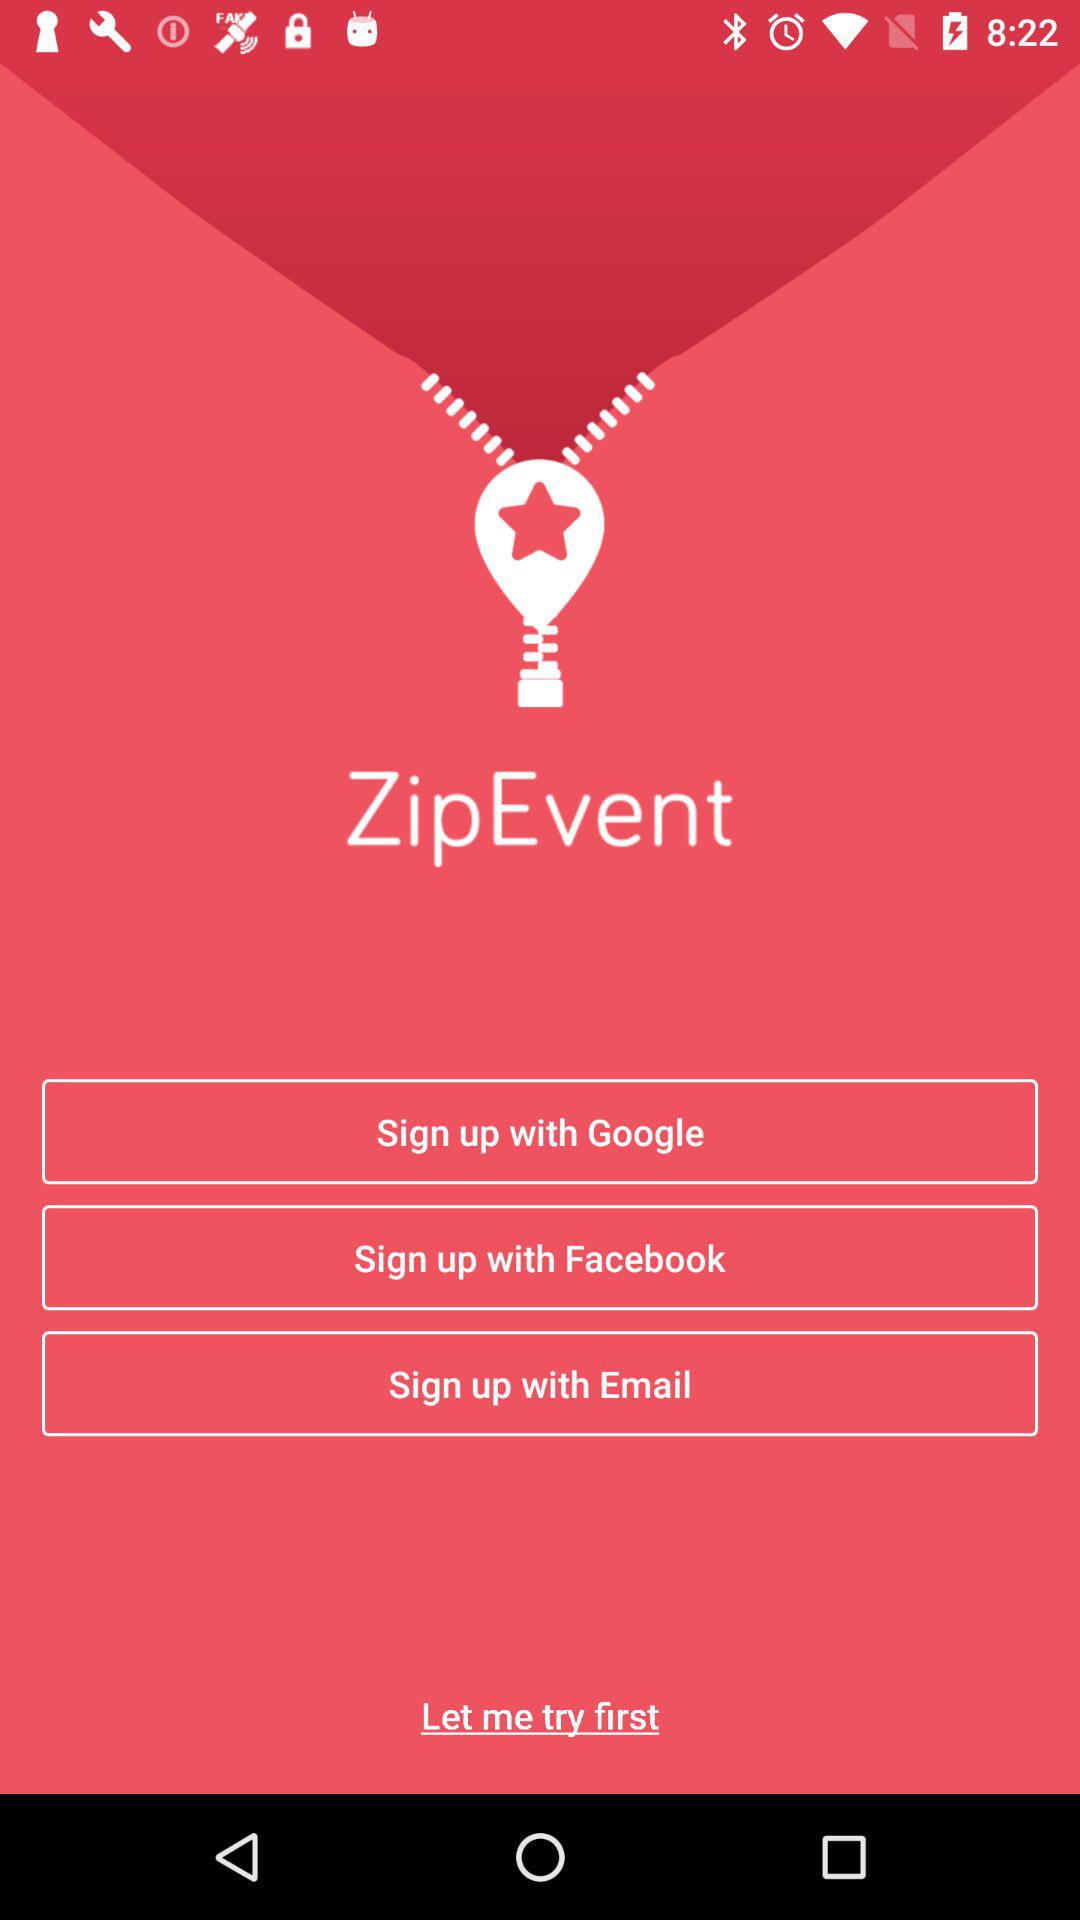What is the app name? The app name is "ZipEvent". 